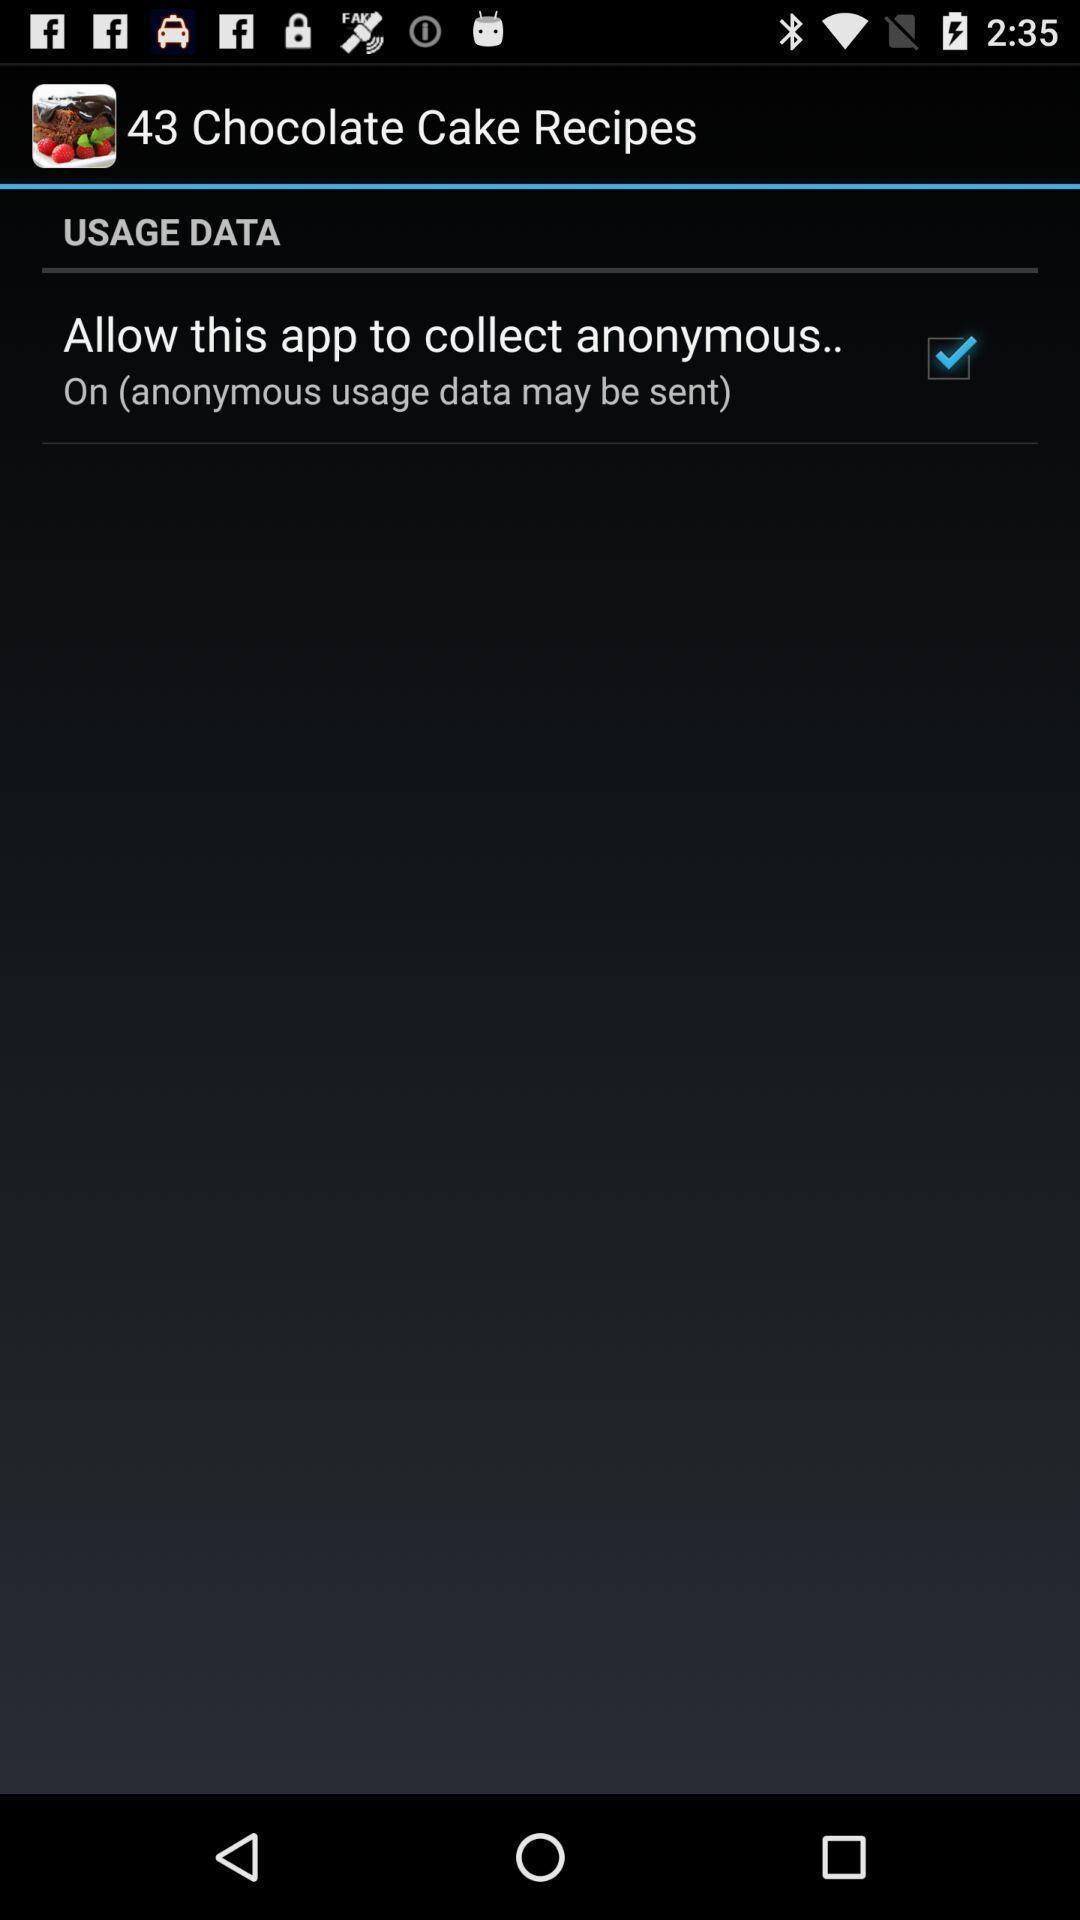What is the overall content of this screenshot? Screen displaying the option to allow. 